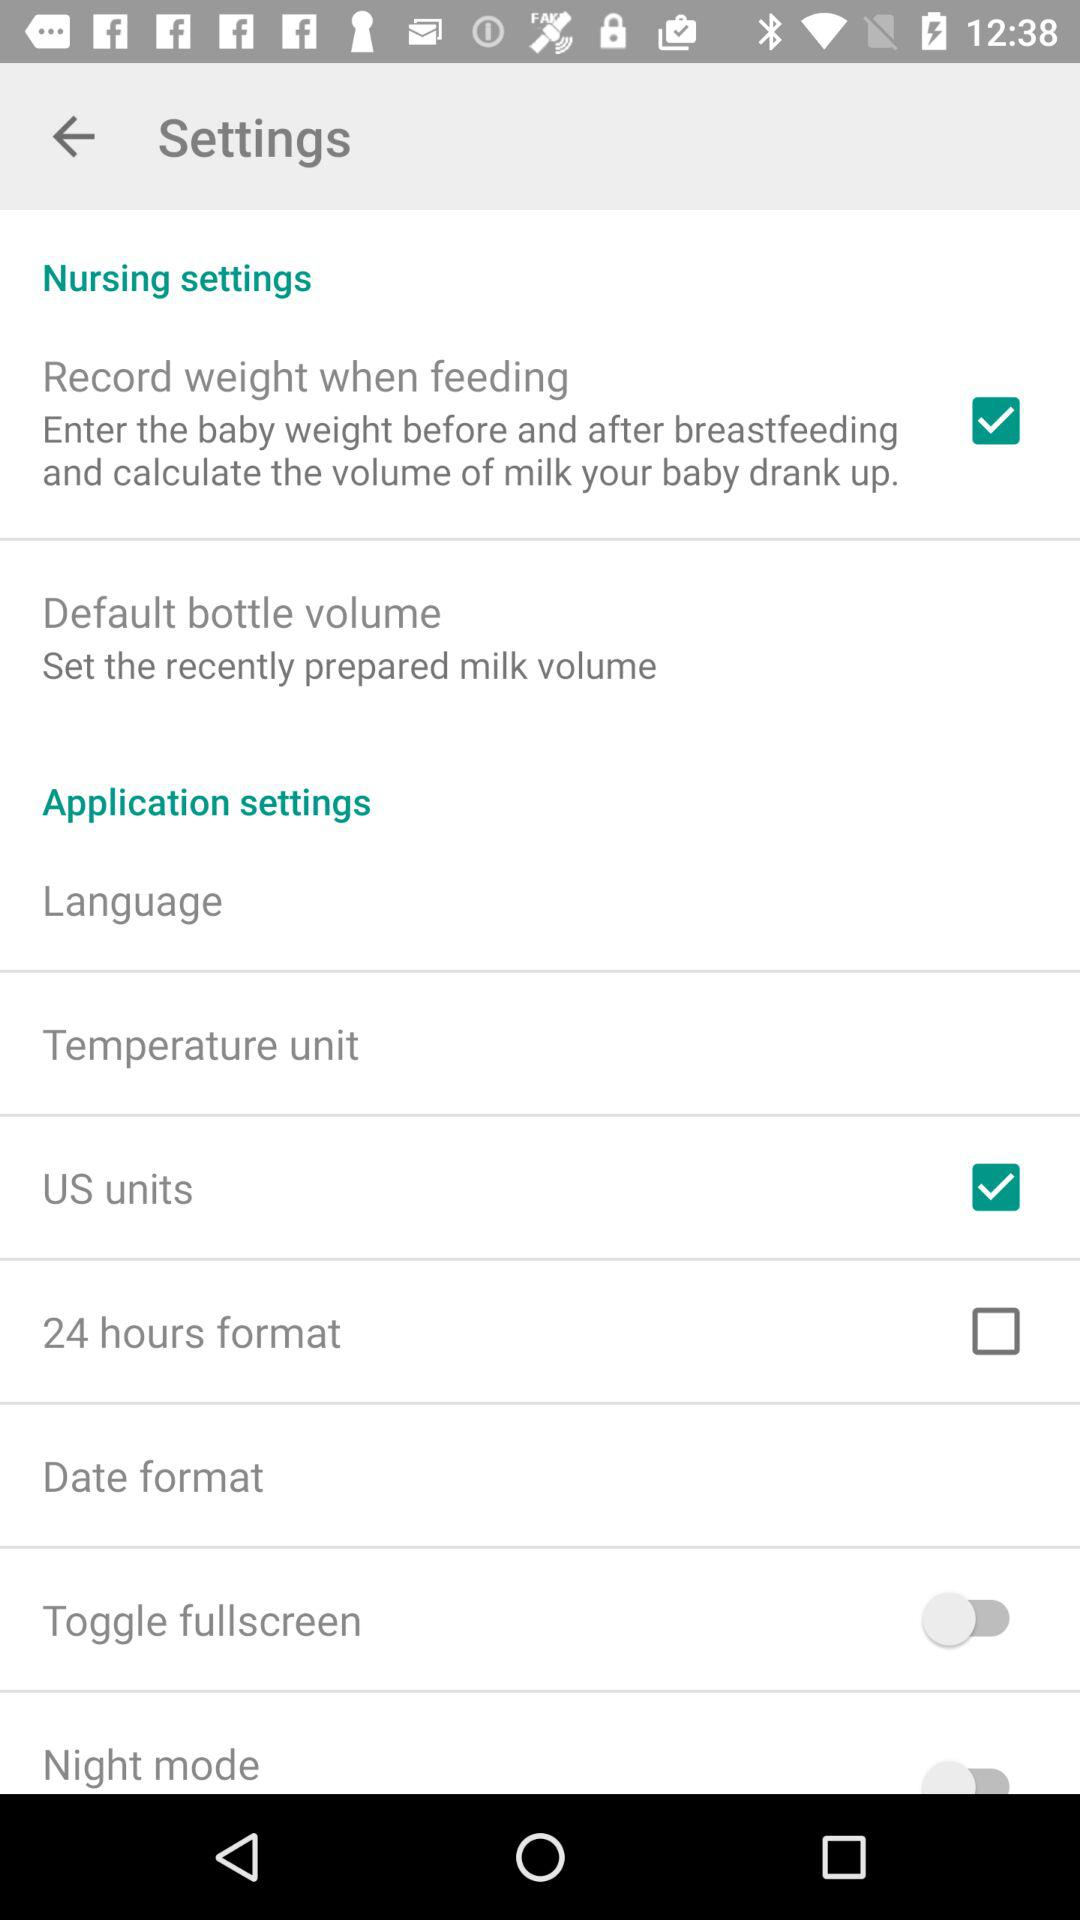Which option is not checked? The option is "24 hours format". 